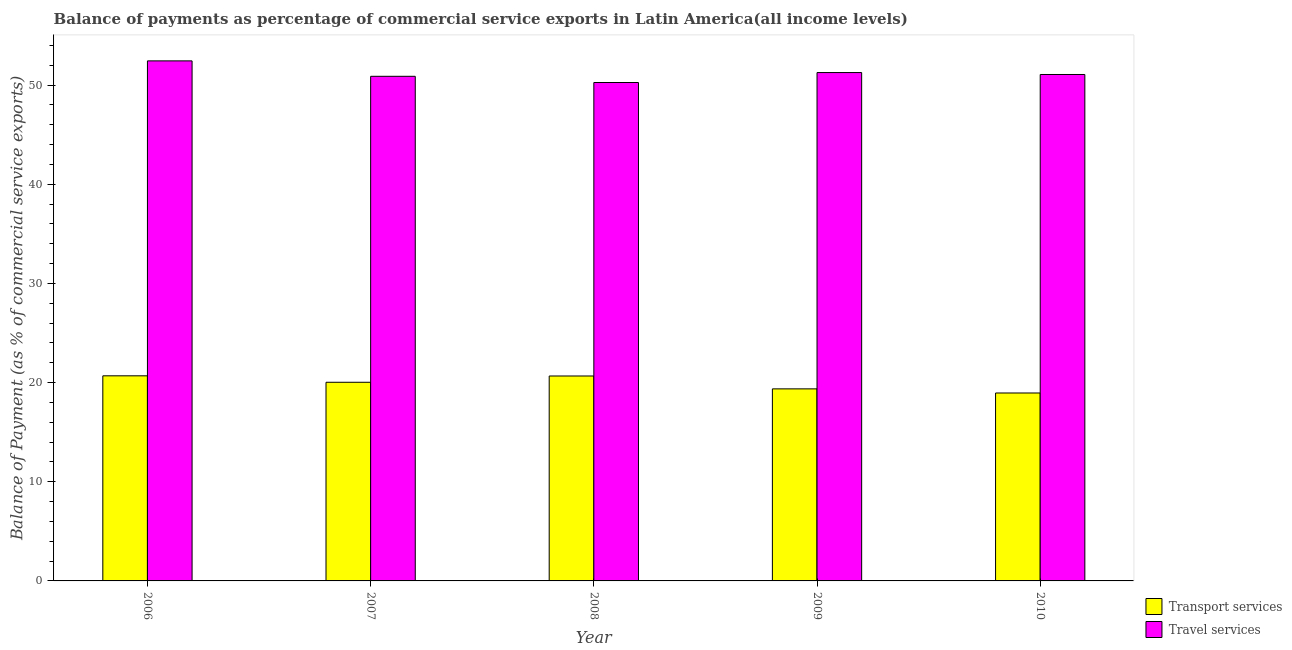Are the number of bars per tick equal to the number of legend labels?
Provide a succinct answer. Yes. Are the number of bars on each tick of the X-axis equal?
Your answer should be compact. Yes. How many bars are there on the 4th tick from the right?
Ensure brevity in your answer.  2. What is the balance of payments of travel services in 2009?
Keep it short and to the point. 51.26. Across all years, what is the maximum balance of payments of travel services?
Ensure brevity in your answer.  52.44. Across all years, what is the minimum balance of payments of transport services?
Your answer should be very brief. 18.95. In which year was the balance of payments of travel services minimum?
Your response must be concise. 2008. What is the total balance of payments of travel services in the graph?
Ensure brevity in your answer.  255.92. What is the difference between the balance of payments of travel services in 2007 and that in 2008?
Offer a terse response. 0.63. What is the difference between the balance of payments of transport services in 2010 and the balance of payments of travel services in 2007?
Offer a terse response. -1.08. What is the average balance of payments of travel services per year?
Ensure brevity in your answer.  51.18. In how many years, is the balance of payments of transport services greater than 18 %?
Give a very brief answer. 5. What is the ratio of the balance of payments of transport services in 2009 to that in 2010?
Your answer should be very brief. 1.02. What is the difference between the highest and the second highest balance of payments of transport services?
Your response must be concise. 0.02. What is the difference between the highest and the lowest balance of payments of transport services?
Keep it short and to the point. 1.73. In how many years, is the balance of payments of travel services greater than the average balance of payments of travel services taken over all years?
Your answer should be very brief. 2. What does the 1st bar from the left in 2008 represents?
Provide a succinct answer. Transport services. What does the 1st bar from the right in 2006 represents?
Your answer should be compact. Travel services. What is the difference between two consecutive major ticks on the Y-axis?
Keep it short and to the point. 10. Are the values on the major ticks of Y-axis written in scientific E-notation?
Keep it short and to the point. No. Where does the legend appear in the graph?
Offer a terse response. Bottom right. How are the legend labels stacked?
Offer a very short reply. Vertical. What is the title of the graph?
Provide a succinct answer. Balance of payments as percentage of commercial service exports in Latin America(all income levels). What is the label or title of the X-axis?
Ensure brevity in your answer.  Year. What is the label or title of the Y-axis?
Provide a succinct answer. Balance of Payment (as % of commercial service exports). What is the Balance of Payment (as % of commercial service exports) in Transport services in 2006?
Ensure brevity in your answer.  20.68. What is the Balance of Payment (as % of commercial service exports) of Travel services in 2006?
Provide a succinct answer. 52.44. What is the Balance of Payment (as % of commercial service exports) in Transport services in 2007?
Ensure brevity in your answer.  20.03. What is the Balance of Payment (as % of commercial service exports) of Travel services in 2007?
Offer a very short reply. 50.89. What is the Balance of Payment (as % of commercial service exports) in Transport services in 2008?
Ensure brevity in your answer.  20.67. What is the Balance of Payment (as % of commercial service exports) in Travel services in 2008?
Your answer should be compact. 50.26. What is the Balance of Payment (as % of commercial service exports) of Transport services in 2009?
Make the answer very short. 19.37. What is the Balance of Payment (as % of commercial service exports) of Travel services in 2009?
Your response must be concise. 51.26. What is the Balance of Payment (as % of commercial service exports) of Transport services in 2010?
Provide a short and direct response. 18.95. What is the Balance of Payment (as % of commercial service exports) in Travel services in 2010?
Offer a very short reply. 51.07. Across all years, what is the maximum Balance of Payment (as % of commercial service exports) of Transport services?
Make the answer very short. 20.68. Across all years, what is the maximum Balance of Payment (as % of commercial service exports) of Travel services?
Provide a succinct answer. 52.44. Across all years, what is the minimum Balance of Payment (as % of commercial service exports) of Transport services?
Your answer should be very brief. 18.95. Across all years, what is the minimum Balance of Payment (as % of commercial service exports) in Travel services?
Give a very brief answer. 50.26. What is the total Balance of Payment (as % of commercial service exports) of Transport services in the graph?
Provide a succinct answer. 99.7. What is the total Balance of Payment (as % of commercial service exports) in Travel services in the graph?
Give a very brief answer. 255.92. What is the difference between the Balance of Payment (as % of commercial service exports) in Transport services in 2006 and that in 2007?
Your answer should be very brief. 0.65. What is the difference between the Balance of Payment (as % of commercial service exports) in Travel services in 2006 and that in 2007?
Keep it short and to the point. 1.56. What is the difference between the Balance of Payment (as % of commercial service exports) in Transport services in 2006 and that in 2008?
Provide a succinct answer. 0.02. What is the difference between the Balance of Payment (as % of commercial service exports) of Travel services in 2006 and that in 2008?
Ensure brevity in your answer.  2.18. What is the difference between the Balance of Payment (as % of commercial service exports) of Transport services in 2006 and that in 2009?
Give a very brief answer. 1.32. What is the difference between the Balance of Payment (as % of commercial service exports) of Travel services in 2006 and that in 2009?
Offer a terse response. 1.18. What is the difference between the Balance of Payment (as % of commercial service exports) of Transport services in 2006 and that in 2010?
Your answer should be compact. 1.73. What is the difference between the Balance of Payment (as % of commercial service exports) in Travel services in 2006 and that in 2010?
Offer a very short reply. 1.37. What is the difference between the Balance of Payment (as % of commercial service exports) of Transport services in 2007 and that in 2008?
Offer a very short reply. -0.63. What is the difference between the Balance of Payment (as % of commercial service exports) of Travel services in 2007 and that in 2008?
Your answer should be compact. 0.63. What is the difference between the Balance of Payment (as % of commercial service exports) of Transport services in 2007 and that in 2009?
Offer a terse response. 0.66. What is the difference between the Balance of Payment (as % of commercial service exports) in Travel services in 2007 and that in 2009?
Your answer should be compact. -0.38. What is the difference between the Balance of Payment (as % of commercial service exports) in Transport services in 2007 and that in 2010?
Offer a very short reply. 1.08. What is the difference between the Balance of Payment (as % of commercial service exports) of Travel services in 2007 and that in 2010?
Your answer should be compact. -0.18. What is the difference between the Balance of Payment (as % of commercial service exports) in Transport services in 2008 and that in 2009?
Provide a short and direct response. 1.3. What is the difference between the Balance of Payment (as % of commercial service exports) in Travel services in 2008 and that in 2009?
Your answer should be compact. -1. What is the difference between the Balance of Payment (as % of commercial service exports) of Transport services in 2008 and that in 2010?
Make the answer very short. 1.71. What is the difference between the Balance of Payment (as % of commercial service exports) in Travel services in 2008 and that in 2010?
Your response must be concise. -0.81. What is the difference between the Balance of Payment (as % of commercial service exports) in Transport services in 2009 and that in 2010?
Your answer should be compact. 0.42. What is the difference between the Balance of Payment (as % of commercial service exports) of Travel services in 2009 and that in 2010?
Your response must be concise. 0.2. What is the difference between the Balance of Payment (as % of commercial service exports) of Transport services in 2006 and the Balance of Payment (as % of commercial service exports) of Travel services in 2007?
Your response must be concise. -30.2. What is the difference between the Balance of Payment (as % of commercial service exports) of Transport services in 2006 and the Balance of Payment (as % of commercial service exports) of Travel services in 2008?
Your answer should be compact. -29.58. What is the difference between the Balance of Payment (as % of commercial service exports) in Transport services in 2006 and the Balance of Payment (as % of commercial service exports) in Travel services in 2009?
Offer a terse response. -30.58. What is the difference between the Balance of Payment (as % of commercial service exports) in Transport services in 2006 and the Balance of Payment (as % of commercial service exports) in Travel services in 2010?
Ensure brevity in your answer.  -30.39. What is the difference between the Balance of Payment (as % of commercial service exports) of Transport services in 2007 and the Balance of Payment (as % of commercial service exports) of Travel services in 2008?
Offer a very short reply. -30.23. What is the difference between the Balance of Payment (as % of commercial service exports) of Transport services in 2007 and the Balance of Payment (as % of commercial service exports) of Travel services in 2009?
Offer a very short reply. -31.23. What is the difference between the Balance of Payment (as % of commercial service exports) of Transport services in 2007 and the Balance of Payment (as % of commercial service exports) of Travel services in 2010?
Provide a succinct answer. -31.04. What is the difference between the Balance of Payment (as % of commercial service exports) of Transport services in 2008 and the Balance of Payment (as % of commercial service exports) of Travel services in 2009?
Offer a terse response. -30.6. What is the difference between the Balance of Payment (as % of commercial service exports) of Transport services in 2008 and the Balance of Payment (as % of commercial service exports) of Travel services in 2010?
Give a very brief answer. -30.4. What is the difference between the Balance of Payment (as % of commercial service exports) of Transport services in 2009 and the Balance of Payment (as % of commercial service exports) of Travel services in 2010?
Your answer should be very brief. -31.7. What is the average Balance of Payment (as % of commercial service exports) in Transport services per year?
Your answer should be compact. 19.94. What is the average Balance of Payment (as % of commercial service exports) in Travel services per year?
Give a very brief answer. 51.18. In the year 2006, what is the difference between the Balance of Payment (as % of commercial service exports) in Transport services and Balance of Payment (as % of commercial service exports) in Travel services?
Keep it short and to the point. -31.76. In the year 2007, what is the difference between the Balance of Payment (as % of commercial service exports) of Transport services and Balance of Payment (as % of commercial service exports) of Travel services?
Make the answer very short. -30.85. In the year 2008, what is the difference between the Balance of Payment (as % of commercial service exports) in Transport services and Balance of Payment (as % of commercial service exports) in Travel services?
Provide a short and direct response. -29.59. In the year 2009, what is the difference between the Balance of Payment (as % of commercial service exports) of Transport services and Balance of Payment (as % of commercial service exports) of Travel services?
Your answer should be very brief. -31.9. In the year 2010, what is the difference between the Balance of Payment (as % of commercial service exports) in Transport services and Balance of Payment (as % of commercial service exports) in Travel services?
Keep it short and to the point. -32.12. What is the ratio of the Balance of Payment (as % of commercial service exports) in Transport services in 2006 to that in 2007?
Make the answer very short. 1.03. What is the ratio of the Balance of Payment (as % of commercial service exports) of Travel services in 2006 to that in 2007?
Your answer should be very brief. 1.03. What is the ratio of the Balance of Payment (as % of commercial service exports) of Travel services in 2006 to that in 2008?
Ensure brevity in your answer.  1.04. What is the ratio of the Balance of Payment (as % of commercial service exports) of Transport services in 2006 to that in 2009?
Give a very brief answer. 1.07. What is the ratio of the Balance of Payment (as % of commercial service exports) in Transport services in 2006 to that in 2010?
Offer a terse response. 1.09. What is the ratio of the Balance of Payment (as % of commercial service exports) of Travel services in 2006 to that in 2010?
Provide a short and direct response. 1.03. What is the ratio of the Balance of Payment (as % of commercial service exports) of Transport services in 2007 to that in 2008?
Offer a very short reply. 0.97. What is the ratio of the Balance of Payment (as % of commercial service exports) of Travel services in 2007 to that in 2008?
Provide a short and direct response. 1.01. What is the ratio of the Balance of Payment (as % of commercial service exports) in Transport services in 2007 to that in 2009?
Your answer should be very brief. 1.03. What is the ratio of the Balance of Payment (as % of commercial service exports) in Travel services in 2007 to that in 2009?
Keep it short and to the point. 0.99. What is the ratio of the Balance of Payment (as % of commercial service exports) in Transport services in 2007 to that in 2010?
Keep it short and to the point. 1.06. What is the ratio of the Balance of Payment (as % of commercial service exports) in Travel services in 2007 to that in 2010?
Provide a short and direct response. 1. What is the ratio of the Balance of Payment (as % of commercial service exports) in Transport services in 2008 to that in 2009?
Make the answer very short. 1.07. What is the ratio of the Balance of Payment (as % of commercial service exports) of Travel services in 2008 to that in 2009?
Provide a short and direct response. 0.98. What is the ratio of the Balance of Payment (as % of commercial service exports) of Transport services in 2008 to that in 2010?
Provide a succinct answer. 1.09. What is the ratio of the Balance of Payment (as % of commercial service exports) of Travel services in 2008 to that in 2010?
Keep it short and to the point. 0.98. What is the ratio of the Balance of Payment (as % of commercial service exports) of Transport services in 2009 to that in 2010?
Your answer should be compact. 1.02. What is the ratio of the Balance of Payment (as % of commercial service exports) in Travel services in 2009 to that in 2010?
Make the answer very short. 1. What is the difference between the highest and the second highest Balance of Payment (as % of commercial service exports) in Transport services?
Your answer should be compact. 0.02. What is the difference between the highest and the second highest Balance of Payment (as % of commercial service exports) in Travel services?
Offer a very short reply. 1.18. What is the difference between the highest and the lowest Balance of Payment (as % of commercial service exports) in Transport services?
Offer a very short reply. 1.73. What is the difference between the highest and the lowest Balance of Payment (as % of commercial service exports) of Travel services?
Your answer should be compact. 2.18. 